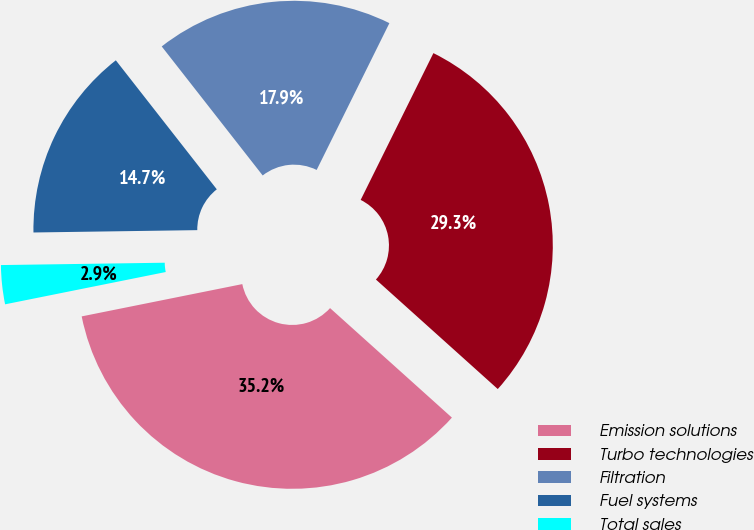Convert chart to OTSL. <chart><loc_0><loc_0><loc_500><loc_500><pie_chart><fcel>Emission solutions<fcel>Turbo technologies<fcel>Filtration<fcel>Fuel systems<fcel>Total sales<nl><fcel>35.19%<fcel>29.33%<fcel>17.89%<fcel>14.66%<fcel>2.93%<nl></chart> 